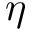Convert formula to latex. <formula><loc_0><loc_0><loc_500><loc_500>\eta</formula> 